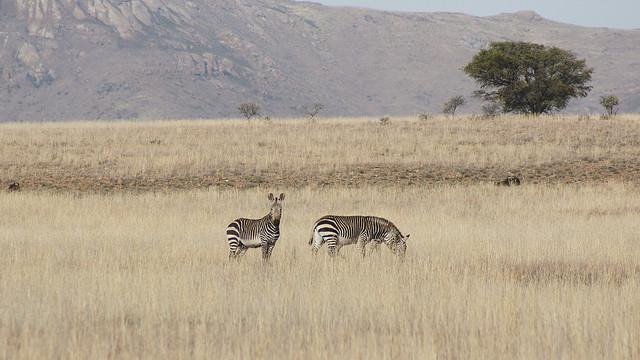How many zebra?
Give a very brief answer. 2. How many animals are partially in the photograph?
Give a very brief answer. 2. How many animal are there?
Give a very brief answer. 2. How many species are in this picture?
Give a very brief answer. 1. How many zebras are in the picture?
Give a very brief answer. 2. How many programs does this laptop have installed?
Give a very brief answer. 0. 